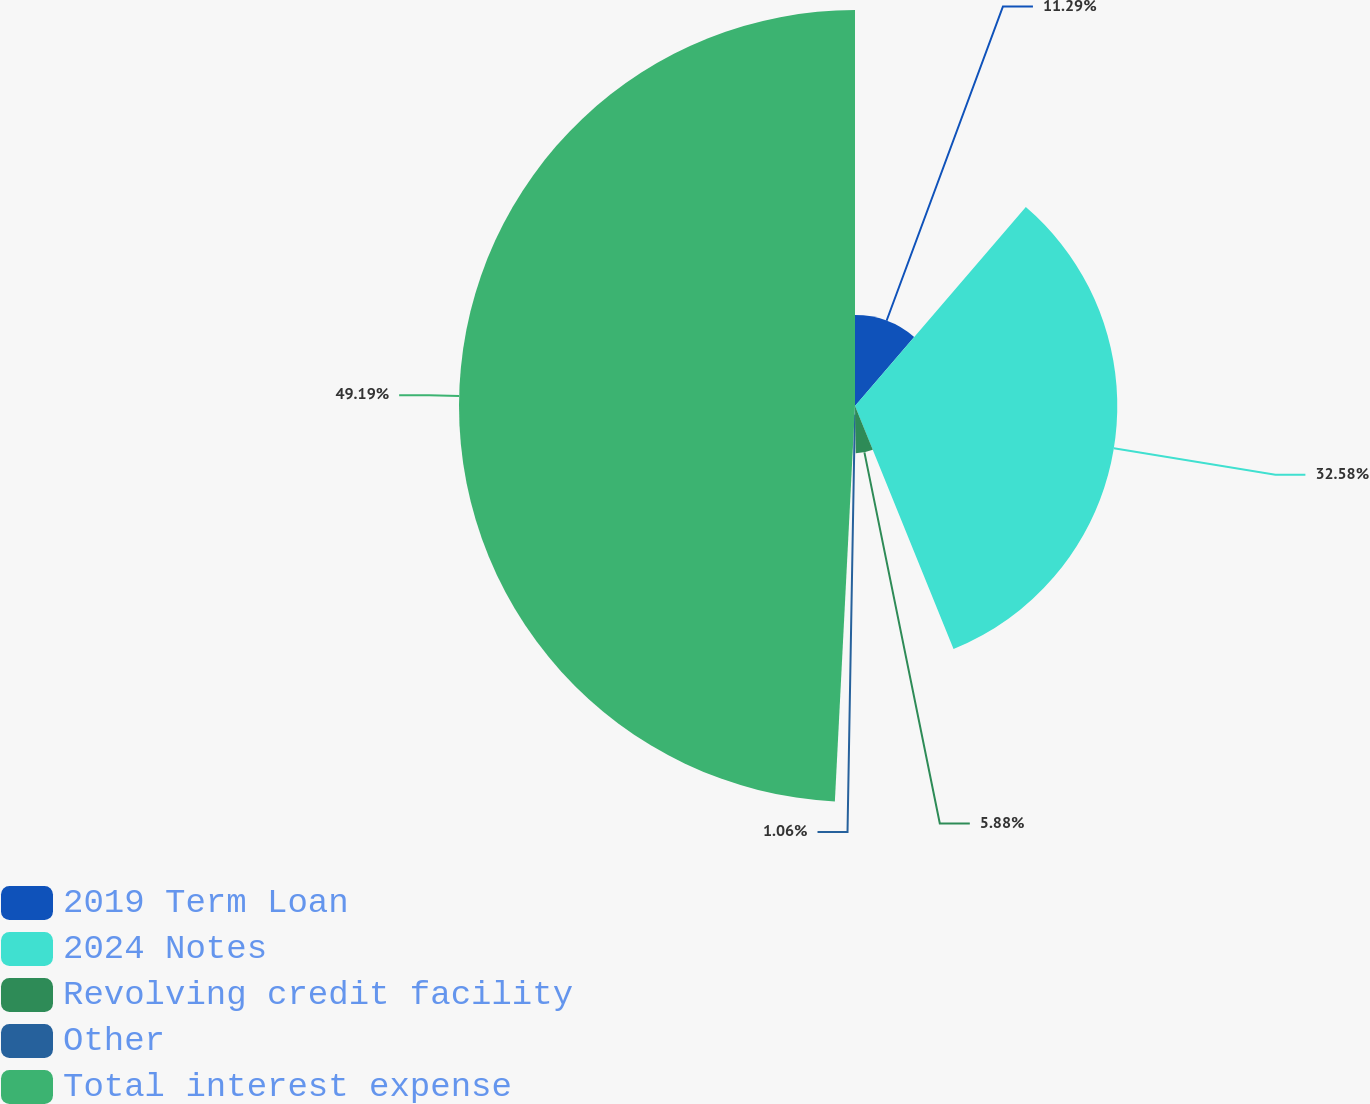Convert chart. <chart><loc_0><loc_0><loc_500><loc_500><pie_chart><fcel>2019 Term Loan<fcel>2024 Notes<fcel>Revolving credit facility<fcel>Other<fcel>Total interest expense<nl><fcel>11.29%<fcel>32.58%<fcel>5.88%<fcel>1.06%<fcel>49.19%<nl></chart> 